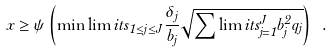<formula> <loc_0><loc_0><loc_500><loc_500>x \geq \psi \left ( { \min \lim i t s _ { 1 \leq j \leq J } \frac { \delta _ { j } } { b _ { j } } \sqrt { \sum \lim i t s _ { j = 1 } ^ { J } { b _ { j } ^ { 2 } { q _ { j } } } } } \right ) \ .</formula> 